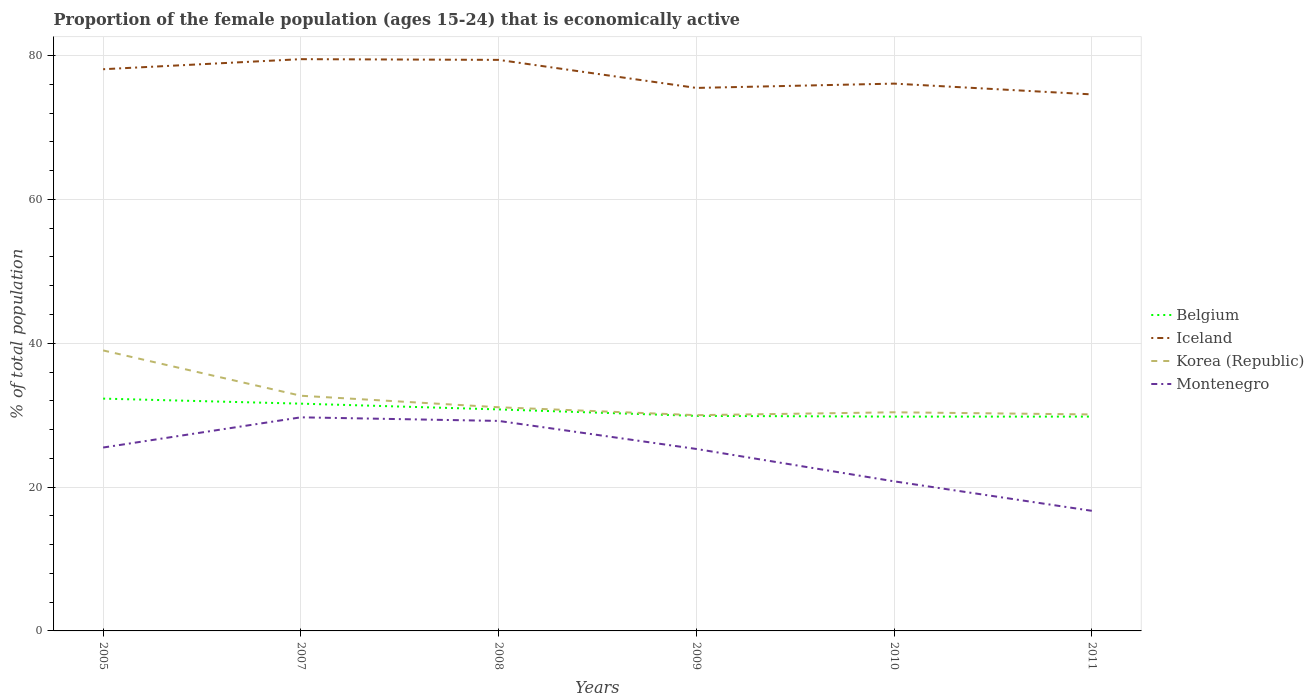Does the line corresponding to Iceland intersect with the line corresponding to Korea (Republic)?
Your answer should be very brief. No. What is the total proportion of the female population that is economically active in Iceland in the graph?
Your answer should be compact. 0.9. What is the difference between the highest and the second highest proportion of the female population that is economically active in Montenegro?
Provide a succinct answer. 13. What is the difference between the highest and the lowest proportion of the female population that is economically active in Iceland?
Your answer should be compact. 3. Are the values on the major ticks of Y-axis written in scientific E-notation?
Offer a terse response. No. Does the graph contain any zero values?
Provide a succinct answer. No. How are the legend labels stacked?
Your answer should be very brief. Vertical. What is the title of the graph?
Offer a very short reply. Proportion of the female population (ages 15-24) that is economically active. What is the label or title of the Y-axis?
Offer a very short reply. % of total population. What is the % of total population in Belgium in 2005?
Provide a short and direct response. 32.3. What is the % of total population in Iceland in 2005?
Your response must be concise. 78.1. What is the % of total population of Korea (Republic) in 2005?
Ensure brevity in your answer.  39. What is the % of total population in Belgium in 2007?
Your answer should be very brief. 31.6. What is the % of total population of Iceland in 2007?
Provide a succinct answer. 79.5. What is the % of total population of Korea (Republic) in 2007?
Make the answer very short. 32.7. What is the % of total population of Montenegro in 2007?
Your answer should be very brief. 29.7. What is the % of total population of Belgium in 2008?
Ensure brevity in your answer.  30.8. What is the % of total population of Iceland in 2008?
Your answer should be very brief. 79.4. What is the % of total population of Korea (Republic) in 2008?
Make the answer very short. 31.1. What is the % of total population in Montenegro in 2008?
Provide a succinct answer. 29.2. What is the % of total population in Belgium in 2009?
Your response must be concise. 29.9. What is the % of total population of Iceland in 2009?
Offer a very short reply. 75.5. What is the % of total population of Korea (Republic) in 2009?
Provide a short and direct response. 30. What is the % of total population in Montenegro in 2009?
Your answer should be very brief. 25.3. What is the % of total population of Belgium in 2010?
Provide a short and direct response. 29.8. What is the % of total population in Iceland in 2010?
Provide a short and direct response. 76.1. What is the % of total population in Korea (Republic) in 2010?
Your answer should be very brief. 30.4. What is the % of total population of Montenegro in 2010?
Ensure brevity in your answer.  20.8. What is the % of total population in Belgium in 2011?
Provide a short and direct response. 29.8. What is the % of total population of Iceland in 2011?
Make the answer very short. 74.6. What is the % of total population of Korea (Republic) in 2011?
Provide a short and direct response. 30.1. What is the % of total population in Montenegro in 2011?
Your answer should be compact. 16.7. Across all years, what is the maximum % of total population in Belgium?
Provide a succinct answer. 32.3. Across all years, what is the maximum % of total population in Iceland?
Make the answer very short. 79.5. Across all years, what is the maximum % of total population of Montenegro?
Make the answer very short. 29.7. Across all years, what is the minimum % of total population of Belgium?
Your answer should be compact. 29.8. Across all years, what is the minimum % of total population of Iceland?
Provide a succinct answer. 74.6. Across all years, what is the minimum % of total population of Korea (Republic)?
Offer a terse response. 30. Across all years, what is the minimum % of total population of Montenegro?
Provide a short and direct response. 16.7. What is the total % of total population in Belgium in the graph?
Provide a succinct answer. 184.2. What is the total % of total population in Iceland in the graph?
Your response must be concise. 463.2. What is the total % of total population of Korea (Republic) in the graph?
Make the answer very short. 193.3. What is the total % of total population in Montenegro in the graph?
Make the answer very short. 147.2. What is the difference between the % of total population of Belgium in 2005 and that in 2007?
Provide a succinct answer. 0.7. What is the difference between the % of total population of Iceland in 2005 and that in 2007?
Keep it short and to the point. -1.4. What is the difference between the % of total population in Belgium in 2005 and that in 2008?
Provide a short and direct response. 1.5. What is the difference between the % of total population in Iceland in 2005 and that in 2008?
Offer a terse response. -1.3. What is the difference between the % of total population of Korea (Republic) in 2005 and that in 2008?
Give a very brief answer. 7.9. What is the difference between the % of total population of Montenegro in 2005 and that in 2008?
Give a very brief answer. -3.7. What is the difference between the % of total population in Belgium in 2005 and that in 2009?
Offer a terse response. 2.4. What is the difference between the % of total population of Iceland in 2005 and that in 2009?
Provide a succinct answer. 2.6. What is the difference between the % of total population of Korea (Republic) in 2005 and that in 2009?
Your answer should be very brief. 9. What is the difference between the % of total population of Montenegro in 2005 and that in 2009?
Offer a very short reply. 0.2. What is the difference between the % of total population of Belgium in 2005 and that in 2010?
Offer a very short reply. 2.5. What is the difference between the % of total population of Korea (Republic) in 2005 and that in 2011?
Give a very brief answer. 8.9. What is the difference between the % of total population of Montenegro in 2005 and that in 2011?
Offer a very short reply. 8.8. What is the difference between the % of total population in Iceland in 2007 and that in 2009?
Ensure brevity in your answer.  4. What is the difference between the % of total population of Korea (Republic) in 2007 and that in 2009?
Your answer should be very brief. 2.7. What is the difference between the % of total population of Montenegro in 2007 and that in 2009?
Your answer should be very brief. 4.4. What is the difference between the % of total population of Iceland in 2007 and that in 2010?
Provide a succinct answer. 3.4. What is the difference between the % of total population of Korea (Republic) in 2007 and that in 2010?
Provide a short and direct response. 2.3. What is the difference between the % of total population in Montenegro in 2007 and that in 2011?
Your answer should be compact. 13. What is the difference between the % of total population in Korea (Republic) in 2008 and that in 2009?
Give a very brief answer. 1.1. What is the difference between the % of total population of Montenegro in 2008 and that in 2010?
Provide a short and direct response. 8.4. What is the difference between the % of total population of Iceland in 2008 and that in 2011?
Your answer should be compact. 4.8. What is the difference between the % of total population of Korea (Republic) in 2008 and that in 2011?
Your answer should be very brief. 1. What is the difference between the % of total population in Montenegro in 2008 and that in 2011?
Ensure brevity in your answer.  12.5. What is the difference between the % of total population of Belgium in 2009 and that in 2010?
Your answer should be compact. 0.1. What is the difference between the % of total population in Iceland in 2009 and that in 2010?
Give a very brief answer. -0.6. What is the difference between the % of total population in Korea (Republic) in 2009 and that in 2010?
Offer a very short reply. -0.4. What is the difference between the % of total population of Belgium in 2009 and that in 2011?
Ensure brevity in your answer.  0.1. What is the difference between the % of total population in Montenegro in 2009 and that in 2011?
Make the answer very short. 8.6. What is the difference between the % of total population of Belgium in 2010 and that in 2011?
Keep it short and to the point. 0. What is the difference between the % of total population of Iceland in 2010 and that in 2011?
Keep it short and to the point. 1.5. What is the difference between the % of total population in Montenegro in 2010 and that in 2011?
Offer a terse response. 4.1. What is the difference between the % of total population of Belgium in 2005 and the % of total population of Iceland in 2007?
Offer a terse response. -47.2. What is the difference between the % of total population in Belgium in 2005 and the % of total population in Korea (Republic) in 2007?
Make the answer very short. -0.4. What is the difference between the % of total population of Iceland in 2005 and the % of total population of Korea (Republic) in 2007?
Give a very brief answer. 45.4. What is the difference between the % of total population in Iceland in 2005 and the % of total population in Montenegro in 2007?
Your answer should be very brief. 48.4. What is the difference between the % of total population of Belgium in 2005 and the % of total population of Iceland in 2008?
Provide a succinct answer. -47.1. What is the difference between the % of total population of Belgium in 2005 and the % of total population of Korea (Republic) in 2008?
Your answer should be compact. 1.2. What is the difference between the % of total population in Iceland in 2005 and the % of total population in Korea (Republic) in 2008?
Provide a succinct answer. 47. What is the difference between the % of total population in Iceland in 2005 and the % of total population in Montenegro in 2008?
Offer a very short reply. 48.9. What is the difference between the % of total population of Belgium in 2005 and the % of total population of Iceland in 2009?
Offer a terse response. -43.2. What is the difference between the % of total population in Iceland in 2005 and the % of total population in Korea (Republic) in 2009?
Ensure brevity in your answer.  48.1. What is the difference between the % of total population in Iceland in 2005 and the % of total population in Montenegro in 2009?
Make the answer very short. 52.8. What is the difference between the % of total population of Korea (Republic) in 2005 and the % of total population of Montenegro in 2009?
Offer a very short reply. 13.7. What is the difference between the % of total population of Belgium in 2005 and the % of total population of Iceland in 2010?
Offer a very short reply. -43.8. What is the difference between the % of total population in Belgium in 2005 and the % of total population in Montenegro in 2010?
Offer a terse response. 11.5. What is the difference between the % of total population in Iceland in 2005 and the % of total population in Korea (Republic) in 2010?
Keep it short and to the point. 47.7. What is the difference between the % of total population of Iceland in 2005 and the % of total population of Montenegro in 2010?
Provide a succinct answer. 57.3. What is the difference between the % of total population of Belgium in 2005 and the % of total population of Iceland in 2011?
Offer a very short reply. -42.3. What is the difference between the % of total population in Belgium in 2005 and the % of total population in Montenegro in 2011?
Provide a short and direct response. 15.6. What is the difference between the % of total population in Iceland in 2005 and the % of total population in Korea (Republic) in 2011?
Ensure brevity in your answer.  48. What is the difference between the % of total population in Iceland in 2005 and the % of total population in Montenegro in 2011?
Ensure brevity in your answer.  61.4. What is the difference between the % of total population in Korea (Republic) in 2005 and the % of total population in Montenegro in 2011?
Keep it short and to the point. 22.3. What is the difference between the % of total population of Belgium in 2007 and the % of total population of Iceland in 2008?
Your response must be concise. -47.8. What is the difference between the % of total population of Belgium in 2007 and the % of total population of Korea (Republic) in 2008?
Offer a very short reply. 0.5. What is the difference between the % of total population in Belgium in 2007 and the % of total population in Montenegro in 2008?
Offer a very short reply. 2.4. What is the difference between the % of total population in Iceland in 2007 and the % of total population in Korea (Republic) in 2008?
Your answer should be very brief. 48.4. What is the difference between the % of total population in Iceland in 2007 and the % of total population in Montenegro in 2008?
Your answer should be very brief. 50.3. What is the difference between the % of total population in Belgium in 2007 and the % of total population in Iceland in 2009?
Ensure brevity in your answer.  -43.9. What is the difference between the % of total population in Iceland in 2007 and the % of total population in Korea (Republic) in 2009?
Offer a very short reply. 49.5. What is the difference between the % of total population of Iceland in 2007 and the % of total population of Montenegro in 2009?
Give a very brief answer. 54.2. What is the difference between the % of total population of Belgium in 2007 and the % of total population of Iceland in 2010?
Offer a terse response. -44.5. What is the difference between the % of total population in Belgium in 2007 and the % of total population in Korea (Republic) in 2010?
Offer a terse response. 1.2. What is the difference between the % of total population of Belgium in 2007 and the % of total population of Montenegro in 2010?
Provide a succinct answer. 10.8. What is the difference between the % of total population in Iceland in 2007 and the % of total population in Korea (Republic) in 2010?
Make the answer very short. 49.1. What is the difference between the % of total population of Iceland in 2007 and the % of total population of Montenegro in 2010?
Make the answer very short. 58.7. What is the difference between the % of total population of Korea (Republic) in 2007 and the % of total population of Montenegro in 2010?
Ensure brevity in your answer.  11.9. What is the difference between the % of total population in Belgium in 2007 and the % of total population in Iceland in 2011?
Give a very brief answer. -43. What is the difference between the % of total population in Belgium in 2007 and the % of total population in Montenegro in 2011?
Offer a terse response. 14.9. What is the difference between the % of total population of Iceland in 2007 and the % of total population of Korea (Republic) in 2011?
Ensure brevity in your answer.  49.4. What is the difference between the % of total population in Iceland in 2007 and the % of total population in Montenegro in 2011?
Ensure brevity in your answer.  62.8. What is the difference between the % of total population of Belgium in 2008 and the % of total population of Iceland in 2009?
Provide a succinct answer. -44.7. What is the difference between the % of total population of Iceland in 2008 and the % of total population of Korea (Republic) in 2009?
Your response must be concise. 49.4. What is the difference between the % of total population in Iceland in 2008 and the % of total population in Montenegro in 2009?
Provide a succinct answer. 54.1. What is the difference between the % of total population in Belgium in 2008 and the % of total population in Iceland in 2010?
Your answer should be very brief. -45.3. What is the difference between the % of total population in Belgium in 2008 and the % of total population in Korea (Republic) in 2010?
Offer a terse response. 0.4. What is the difference between the % of total population of Belgium in 2008 and the % of total population of Montenegro in 2010?
Your answer should be compact. 10. What is the difference between the % of total population of Iceland in 2008 and the % of total population of Montenegro in 2010?
Ensure brevity in your answer.  58.6. What is the difference between the % of total population in Belgium in 2008 and the % of total population in Iceland in 2011?
Your response must be concise. -43.8. What is the difference between the % of total population of Iceland in 2008 and the % of total population of Korea (Republic) in 2011?
Give a very brief answer. 49.3. What is the difference between the % of total population of Iceland in 2008 and the % of total population of Montenegro in 2011?
Offer a terse response. 62.7. What is the difference between the % of total population of Belgium in 2009 and the % of total population of Iceland in 2010?
Your response must be concise. -46.2. What is the difference between the % of total population in Iceland in 2009 and the % of total population in Korea (Republic) in 2010?
Give a very brief answer. 45.1. What is the difference between the % of total population in Iceland in 2009 and the % of total population in Montenegro in 2010?
Give a very brief answer. 54.7. What is the difference between the % of total population of Belgium in 2009 and the % of total population of Iceland in 2011?
Make the answer very short. -44.7. What is the difference between the % of total population in Belgium in 2009 and the % of total population in Korea (Republic) in 2011?
Your answer should be compact. -0.2. What is the difference between the % of total population in Iceland in 2009 and the % of total population in Korea (Republic) in 2011?
Your answer should be compact. 45.4. What is the difference between the % of total population of Iceland in 2009 and the % of total population of Montenegro in 2011?
Your answer should be compact. 58.8. What is the difference between the % of total population of Belgium in 2010 and the % of total population of Iceland in 2011?
Your response must be concise. -44.8. What is the difference between the % of total population of Belgium in 2010 and the % of total population of Korea (Republic) in 2011?
Keep it short and to the point. -0.3. What is the difference between the % of total population in Iceland in 2010 and the % of total population in Montenegro in 2011?
Ensure brevity in your answer.  59.4. What is the difference between the % of total population in Korea (Republic) in 2010 and the % of total population in Montenegro in 2011?
Your response must be concise. 13.7. What is the average % of total population in Belgium per year?
Ensure brevity in your answer.  30.7. What is the average % of total population of Iceland per year?
Make the answer very short. 77.2. What is the average % of total population of Korea (Republic) per year?
Give a very brief answer. 32.22. What is the average % of total population in Montenegro per year?
Provide a short and direct response. 24.53. In the year 2005, what is the difference between the % of total population in Belgium and % of total population in Iceland?
Provide a succinct answer. -45.8. In the year 2005, what is the difference between the % of total population in Belgium and % of total population in Montenegro?
Ensure brevity in your answer.  6.8. In the year 2005, what is the difference between the % of total population in Iceland and % of total population in Korea (Republic)?
Provide a succinct answer. 39.1. In the year 2005, what is the difference between the % of total population in Iceland and % of total population in Montenegro?
Offer a very short reply. 52.6. In the year 2007, what is the difference between the % of total population of Belgium and % of total population of Iceland?
Your answer should be compact. -47.9. In the year 2007, what is the difference between the % of total population of Belgium and % of total population of Korea (Republic)?
Offer a terse response. -1.1. In the year 2007, what is the difference between the % of total population in Belgium and % of total population in Montenegro?
Keep it short and to the point. 1.9. In the year 2007, what is the difference between the % of total population of Iceland and % of total population of Korea (Republic)?
Give a very brief answer. 46.8. In the year 2007, what is the difference between the % of total population in Iceland and % of total population in Montenegro?
Make the answer very short. 49.8. In the year 2007, what is the difference between the % of total population of Korea (Republic) and % of total population of Montenegro?
Provide a short and direct response. 3. In the year 2008, what is the difference between the % of total population of Belgium and % of total population of Iceland?
Keep it short and to the point. -48.6. In the year 2008, what is the difference between the % of total population of Belgium and % of total population of Montenegro?
Your response must be concise. 1.6. In the year 2008, what is the difference between the % of total population in Iceland and % of total population in Korea (Republic)?
Offer a terse response. 48.3. In the year 2008, what is the difference between the % of total population of Iceland and % of total population of Montenegro?
Offer a terse response. 50.2. In the year 2008, what is the difference between the % of total population in Korea (Republic) and % of total population in Montenegro?
Your answer should be very brief. 1.9. In the year 2009, what is the difference between the % of total population of Belgium and % of total population of Iceland?
Your answer should be compact. -45.6. In the year 2009, what is the difference between the % of total population in Iceland and % of total population in Korea (Republic)?
Offer a terse response. 45.5. In the year 2009, what is the difference between the % of total population in Iceland and % of total population in Montenegro?
Ensure brevity in your answer.  50.2. In the year 2009, what is the difference between the % of total population in Korea (Republic) and % of total population in Montenegro?
Offer a very short reply. 4.7. In the year 2010, what is the difference between the % of total population of Belgium and % of total population of Iceland?
Your response must be concise. -46.3. In the year 2010, what is the difference between the % of total population in Belgium and % of total population in Montenegro?
Ensure brevity in your answer.  9. In the year 2010, what is the difference between the % of total population in Iceland and % of total population in Korea (Republic)?
Ensure brevity in your answer.  45.7. In the year 2010, what is the difference between the % of total population in Iceland and % of total population in Montenegro?
Your answer should be very brief. 55.3. In the year 2010, what is the difference between the % of total population in Korea (Republic) and % of total population in Montenegro?
Offer a very short reply. 9.6. In the year 2011, what is the difference between the % of total population in Belgium and % of total population in Iceland?
Offer a very short reply. -44.8. In the year 2011, what is the difference between the % of total population in Belgium and % of total population in Montenegro?
Offer a very short reply. 13.1. In the year 2011, what is the difference between the % of total population of Iceland and % of total population of Korea (Republic)?
Keep it short and to the point. 44.5. In the year 2011, what is the difference between the % of total population in Iceland and % of total population in Montenegro?
Your answer should be very brief. 57.9. What is the ratio of the % of total population of Belgium in 2005 to that in 2007?
Make the answer very short. 1.02. What is the ratio of the % of total population in Iceland in 2005 to that in 2007?
Your answer should be very brief. 0.98. What is the ratio of the % of total population of Korea (Republic) in 2005 to that in 2007?
Your answer should be very brief. 1.19. What is the ratio of the % of total population of Montenegro in 2005 to that in 2007?
Provide a succinct answer. 0.86. What is the ratio of the % of total population in Belgium in 2005 to that in 2008?
Your answer should be compact. 1.05. What is the ratio of the % of total population of Iceland in 2005 to that in 2008?
Keep it short and to the point. 0.98. What is the ratio of the % of total population in Korea (Republic) in 2005 to that in 2008?
Your answer should be very brief. 1.25. What is the ratio of the % of total population of Montenegro in 2005 to that in 2008?
Your answer should be very brief. 0.87. What is the ratio of the % of total population in Belgium in 2005 to that in 2009?
Provide a succinct answer. 1.08. What is the ratio of the % of total population of Iceland in 2005 to that in 2009?
Your answer should be very brief. 1.03. What is the ratio of the % of total population in Korea (Republic) in 2005 to that in 2009?
Make the answer very short. 1.3. What is the ratio of the % of total population of Montenegro in 2005 to that in 2009?
Offer a terse response. 1.01. What is the ratio of the % of total population in Belgium in 2005 to that in 2010?
Your answer should be very brief. 1.08. What is the ratio of the % of total population of Iceland in 2005 to that in 2010?
Your response must be concise. 1.03. What is the ratio of the % of total population in Korea (Republic) in 2005 to that in 2010?
Your answer should be very brief. 1.28. What is the ratio of the % of total population in Montenegro in 2005 to that in 2010?
Make the answer very short. 1.23. What is the ratio of the % of total population in Belgium in 2005 to that in 2011?
Offer a very short reply. 1.08. What is the ratio of the % of total population of Iceland in 2005 to that in 2011?
Make the answer very short. 1.05. What is the ratio of the % of total population of Korea (Republic) in 2005 to that in 2011?
Keep it short and to the point. 1.3. What is the ratio of the % of total population in Montenegro in 2005 to that in 2011?
Your response must be concise. 1.53. What is the ratio of the % of total population in Belgium in 2007 to that in 2008?
Offer a very short reply. 1.03. What is the ratio of the % of total population in Korea (Republic) in 2007 to that in 2008?
Provide a short and direct response. 1.05. What is the ratio of the % of total population of Montenegro in 2007 to that in 2008?
Your response must be concise. 1.02. What is the ratio of the % of total population in Belgium in 2007 to that in 2009?
Ensure brevity in your answer.  1.06. What is the ratio of the % of total population of Iceland in 2007 to that in 2009?
Your answer should be very brief. 1.05. What is the ratio of the % of total population in Korea (Republic) in 2007 to that in 2009?
Provide a succinct answer. 1.09. What is the ratio of the % of total population in Montenegro in 2007 to that in 2009?
Provide a succinct answer. 1.17. What is the ratio of the % of total population of Belgium in 2007 to that in 2010?
Provide a short and direct response. 1.06. What is the ratio of the % of total population of Iceland in 2007 to that in 2010?
Give a very brief answer. 1.04. What is the ratio of the % of total population in Korea (Republic) in 2007 to that in 2010?
Give a very brief answer. 1.08. What is the ratio of the % of total population in Montenegro in 2007 to that in 2010?
Your response must be concise. 1.43. What is the ratio of the % of total population in Belgium in 2007 to that in 2011?
Give a very brief answer. 1.06. What is the ratio of the % of total population of Iceland in 2007 to that in 2011?
Your answer should be compact. 1.07. What is the ratio of the % of total population in Korea (Republic) in 2007 to that in 2011?
Give a very brief answer. 1.09. What is the ratio of the % of total population in Montenegro in 2007 to that in 2011?
Provide a succinct answer. 1.78. What is the ratio of the % of total population of Belgium in 2008 to that in 2009?
Keep it short and to the point. 1.03. What is the ratio of the % of total population in Iceland in 2008 to that in 2009?
Your response must be concise. 1.05. What is the ratio of the % of total population of Korea (Republic) in 2008 to that in 2009?
Make the answer very short. 1.04. What is the ratio of the % of total population in Montenegro in 2008 to that in 2009?
Make the answer very short. 1.15. What is the ratio of the % of total population of Belgium in 2008 to that in 2010?
Your answer should be compact. 1.03. What is the ratio of the % of total population of Iceland in 2008 to that in 2010?
Ensure brevity in your answer.  1.04. What is the ratio of the % of total population of Korea (Republic) in 2008 to that in 2010?
Offer a terse response. 1.02. What is the ratio of the % of total population in Montenegro in 2008 to that in 2010?
Give a very brief answer. 1.4. What is the ratio of the % of total population of Belgium in 2008 to that in 2011?
Make the answer very short. 1.03. What is the ratio of the % of total population in Iceland in 2008 to that in 2011?
Your response must be concise. 1.06. What is the ratio of the % of total population in Korea (Republic) in 2008 to that in 2011?
Provide a succinct answer. 1.03. What is the ratio of the % of total population in Montenegro in 2008 to that in 2011?
Your answer should be compact. 1.75. What is the ratio of the % of total population in Belgium in 2009 to that in 2010?
Your answer should be compact. 1. What is the ratio of the % of total population in Iceland in 2009 to that in 2010?
Ensure brevity in your answer.  0.99. What is the ratio of the % of total population in Korea (Republic) in 2009 to that in 2010?
Your answer should be compact. 0.99. What is the ratio of the % of total population of Montenegro in 2009 to that in 2010?
Offer a terse response. 1.22. What is the ratio of the % of total population in Iceland in 2009 to that in 2011?
Give a very brief answer. 1.01. What is the ratio of the % of total population of Korea (Republic) in 2009 to that in 2011?
Offer a very short reply. 1. What is the ratio of the % of total population of Montenegro in 2009 to that in 2011?
Offer a very short reply. 1.51. What is the ratio of the % of total population in Belgium in 2010 to that in 2011?
Provide a short and direct response. 1. What is the ratio of the % of total population in Iceland in 2010 to that in 2011?
Provide a short and direct response. 1.02. What is the ratio of the % of total population of Montenegro in 2010 to that in 2011?
Keep it short and to the point. 1.25. What is the difference between the highest and the second highest % of total population of Iceland?
Your answer should be compact. 0.1. What is the difference between the highest and the second highest % of total population in Montenegro?
Your answer should be compact. 0.5. What is the difference between the highest and the lowest % of total population in Belgium?
Offer a terse response. 2.5. What is the difference between the highest and the lowest % of total population of Iceland?
Your answer should be compact. 4.9. What is the difference between the highest and the lowest % of total population of Korea (Republic)?
Provide a short and direct response. 9. 